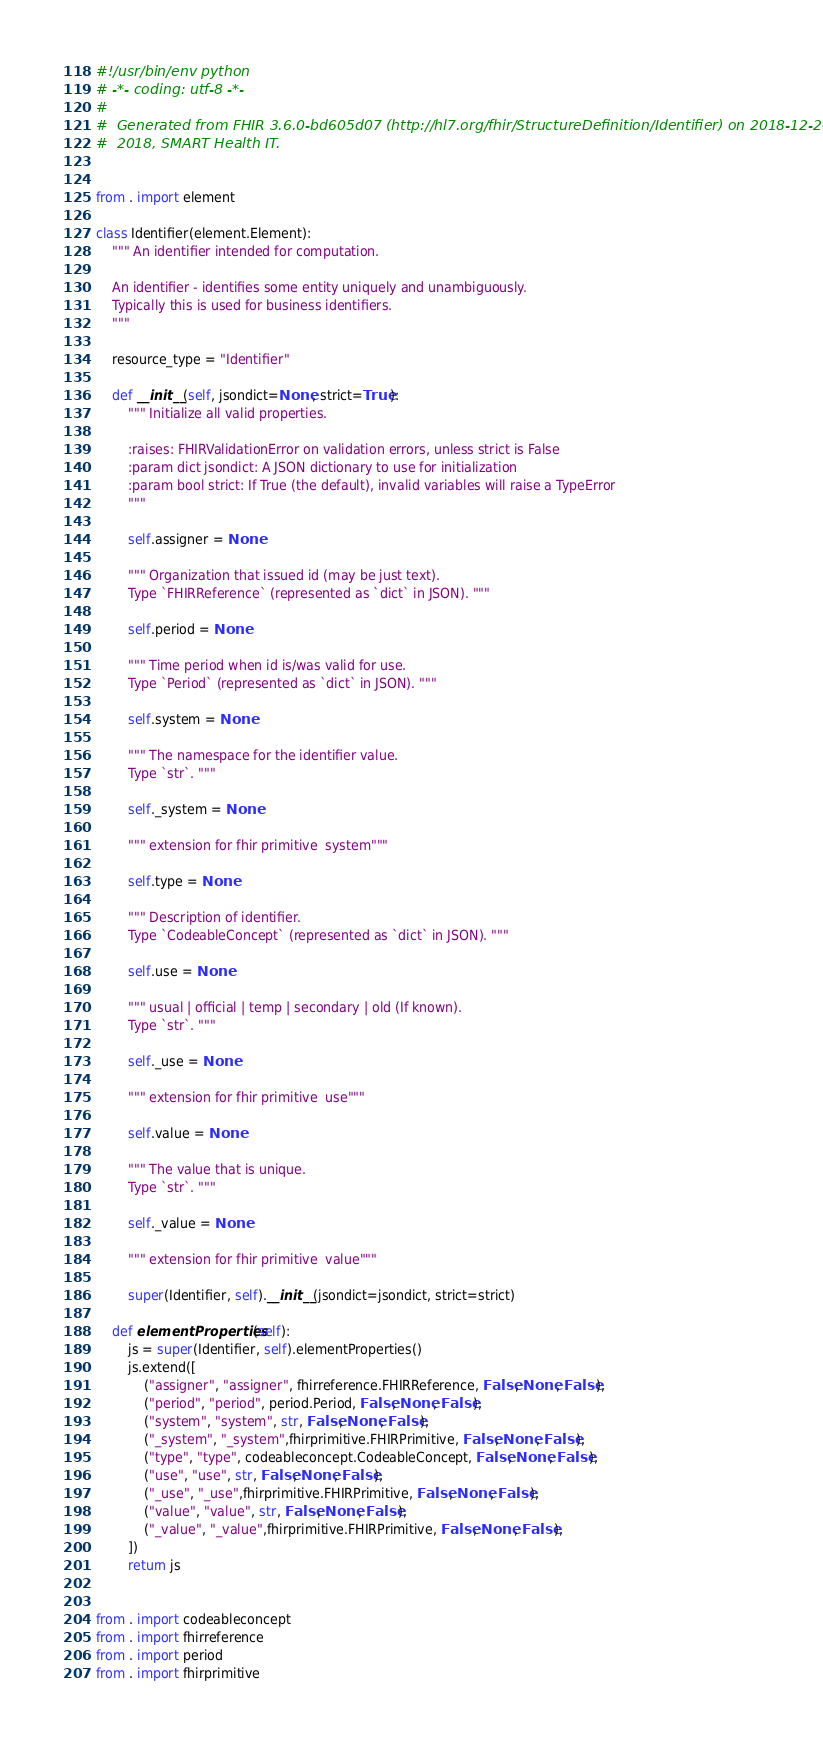<code> <loc_0><loc_0><loc_500><loc_500><_Python_>#!/usr/bin/env python
# -*- coding: utf-8 -*-
#
#  Generated from FHIR 3.6.0-bd605d07 (http://hl7.org/fhir/StructureDefinition/Identifier) on 2018-12-20.
#  2018, SMART Health IT.


from . import element

class Identifier(element.Element):
    """ An identifier intended for computation.
    
    An identifier - identifies some entity uniquely and unambiguously.
    Typically this is used for business identifiers.
    """
    
    resource_type = "Identifier"
    
    def __init__(self, jsondict=None, strict=True):
        """ Initialize all valid properties.
        
        :raises: FHIRValidationError on validation errors, unless strict is False
        :param dict jsondict: A JSON dictionary to use for initialization
        :param bool strict: If True (the default), invalid variables will raise a TypeError
        """
        
        self.assigner = None
        
        """ Organization that issued id (may be just text).
        Type `FHIRReference` (represented as `dict` in JSON). """
        
        self.period = None
        
        """ Time period when id is/was valid for use.
        Type `Period` (represented as `dict` in JSON). """
        
        self.system = None
        
        """ The namespace for the identifier value.
        Type `str`. """
        
        self._system = None
        
        """ extension for fhir primitive  system"""
        
        self.type = None
        
        """ Description of identifier.
        Type `CodeableConcept` (represented as `dict` in JSON). """
        
        self.use = None
        
        """ usual | official | temp | secondary | old (If known).
        Type `str`. """
        
        self._use = None
        
        """ extension for fhir primitive  use"""
        
        self.value = None
        
        """ The value that is unique.
        Type `str`. """
        
        self._value = None
        
        """ extension for fhir primitive  value"""
        
        super(Identifier, self).__init__(jsondict=jsondict, strict=strict)

    def elementProperties(self):
        js = super(Identifier, self).elementProperties()
        js.extend([
            ("assigner", "assigner", fhirreference.FHIRReference, False, None, False),
            ("period", "period", period.Period, False, None, False),
            ("system", "system", str, False, None, False),
            ("_system", "_system",fhirprimitive.FHIRPrimitive, False, None, False),
            ("type", "type", codeableconcept.CodeableConcept, False, None, False),
            ("use", "use", str, False, None, False),
            ("_use", "_use",fhirprimitive.FHIRPrimitive, False, None, False),
            ("value", "value", str, False, None, False),
            ("_value", "_value",fhirprimitive.FHIRPrimitive, False, None, False),
        ])
        return js


from . import codeableconcept
from . import fhirreference
from . import period
from . import fhirprimitive

</code> 